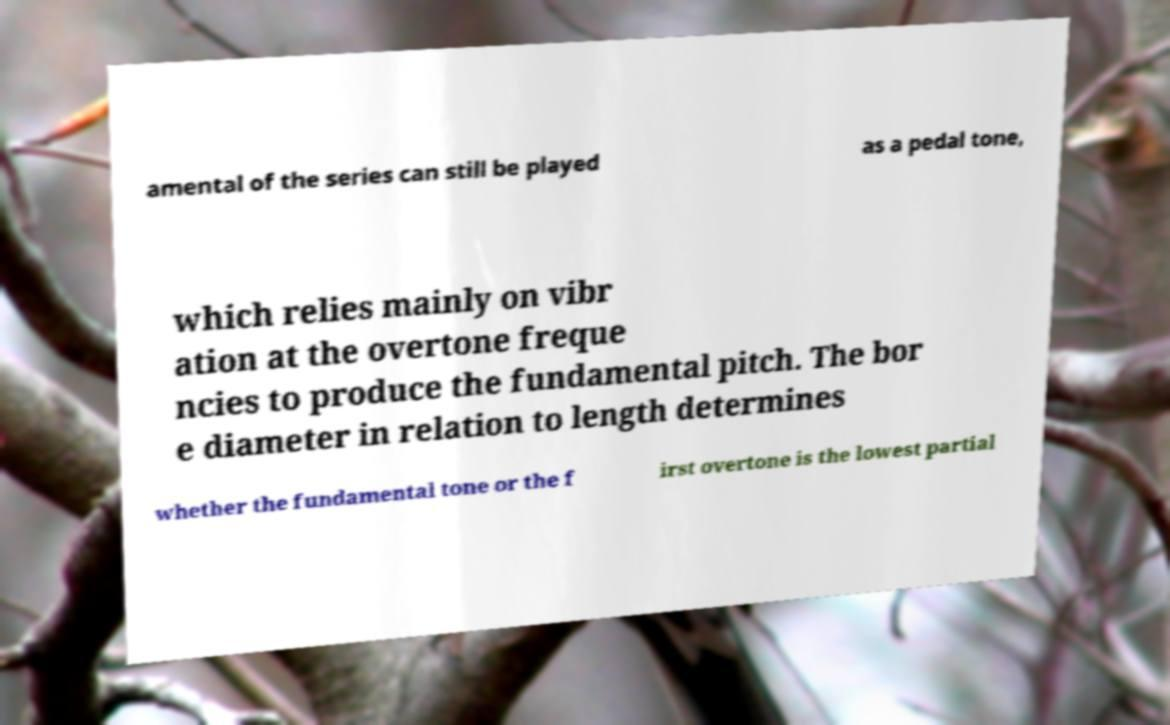Could you extract and type out the text from this image? amental of the series can still be played as a pedal tone, which relies mainly on vibr ation at the overtone freque ncies to produce the fundamental pitch. The bor e diameter in relation to length determines whether the fundamental tone or the f irst overtone is the lowest partial 